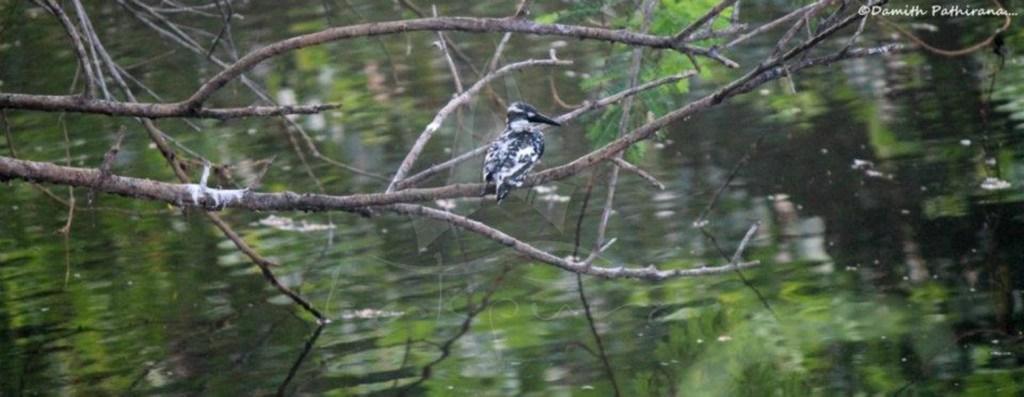Can you describe this image briefly? There is a bird sitting on a branch of a tree. In the back there is water. And there is a watermark in the right top corner. 